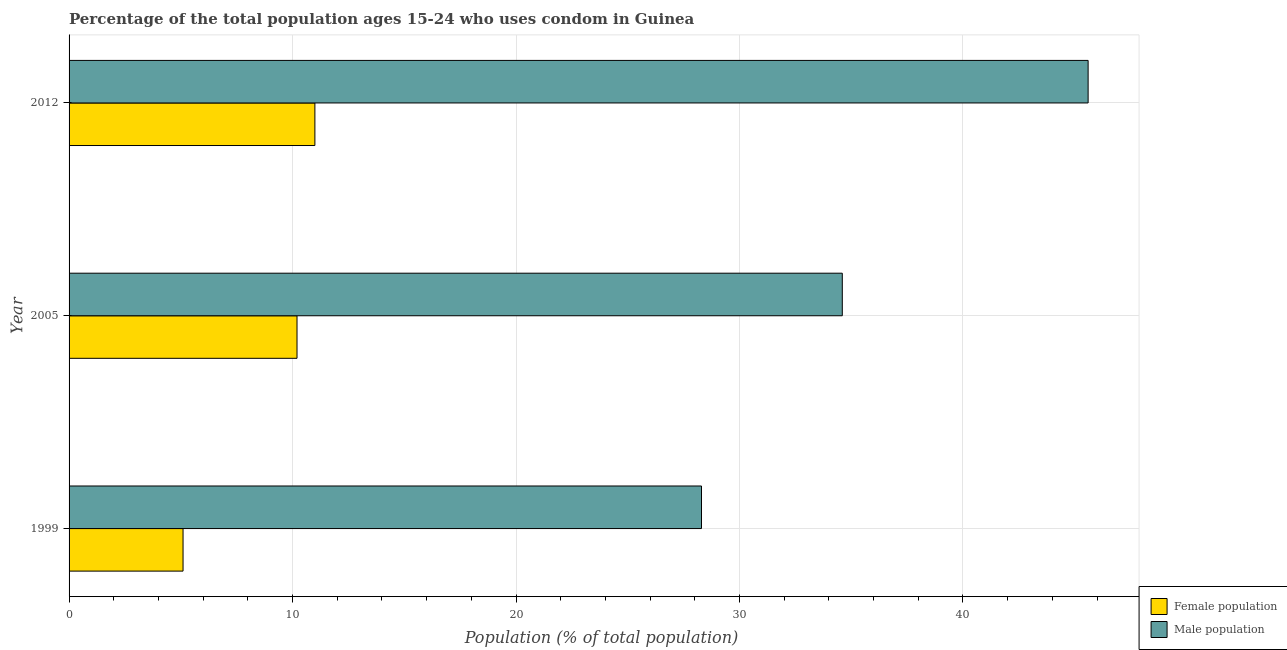How many different coloured bars are there?
Give a very brief answer. 2. How many bars are there on the 2nd tick from the bottom?
Give a very brief answer. 2. In how many cases, is the number of bars for a given year not equal to the number of legend labels?
Your answer should be compact. 0. What is the male population in 1999?
Your answer should be very brief. 28.3. Across all years, what is the maximum male population?
Keep it short and to the point. 45.6. In which year was the male population maximum?
Offer a terse response. 2012. In which year was the female population minimum?
Offer a terse response. 1999. What is the total female population in the graph?
Keep it short and to the point. 26.3. What is the difference between the male population in 2005 and the female population in 2012?
Give a very brief answer. 23.6. What is the average male population per year?
Your response must be concise. 36.17. In the year 1999, what is the difference between the male population and female population?
Make the answer very short. 23.2. In how many years, is the female population greater than 34 %?
Your answer should be very brief. 0. What is the ratio of the male population in 2005 to that in 2012?
Offer a very short reply. 0.76. Is the male population in 1999 less than that in 2012?
Offer a very short reply. Yes. Is the difference between the female population in 1999 and 2005 greater than the difference between the male population in 1999 and 2005?
Give a very brief answer. Yes. What is the difference between the highest and the second highest female population?
Give a very brief answer. 0.8. Is the sum of the female population in 1999 and 2012 greater than the maximum male population across all years?
Your answer should be very brief. No. What does the 2nd bar from the top in 2005 represents?
Offer a terse response. Female population. What does the 1st bar from the bottom in 2012 represents?
Your answer should be compact. Female population. Are the values on the major ticks of X-axis written in scientific E-notation?
Offer a very short reply. No. Does the graph contain grids?
Offer a very short reply. Yes. How are the legend labels stacked?
Offer a terse response. Vertical. What is the title of the graph?
Make the answer very short. Percentage of the total population ages 15-24 who uses condom in Guinea. Does "GDP" appear as one of the legend labels in the graph?
Your answer should be very brief. No. What is the label or title of the X-axis?
Provide a succinct answer. Population (% of total population) . What is the label or title of the Y-axis?
Your answer should be compact. Year. What is the Population (% of total population)  in Female population in 1999?
Keep it short and to the point. 5.1. What is the Population (% of total population)  of Male population in 1999?
Keep it short and to the point. 28.3. What is the Population (% of total population)  in Female population in 2005?
Keep it short and to the point. 10.2. What is the Population (% of total population)  of Male population in 2005?
Your response must be concise. 34.6. What is the Population (% of total population)  of Male population in 2012?
Ensure brevity in your answer.  45.6. Across all years, what is the maximum Population (% of total population)  of Female population?
Provide a succinct answer. 11. Across all years, what is the maximum Population (% of total population)  in Male population?
Provide a succinct answer. 45.6. Across all years, what is the minimum Population (% of total population)  of Female population?
Give a very brief answer. 5.1. Across all years, what is the minimum Population (% of total population)  of Male population?
Provide a succinct answer. 28.3. What is the total Population (% of total population)  in Female population in the graph?
Your answer should be compact. 26.3. What is the total Population (% of total population)  of Male population in the graph?
Ensure brevity in your answer.  108.5. What is the difference between the Population (% of total population)  of Female population in 1999 and that in 2005?
Your response must be concise. -5.1. What is the difference between the Population (% of total population)  of Male population in 1999 and that in 2005?
Your response must be concise. -6.3. What is the difference between the Population (% of total population)  in Male population in 1999 and that in 2012?
Give a very brief answer. -17.3. What is the difference between the Population (% of total population)  in Male population in 2005 and that in 2012?
Provide a short and direct response. -11. What is the difference between the Population (% of total population)  of Female population in 1999 and the Population (% of total population)  of Male population in 2005?
Your answer should be very brief. -29.5. What is the difference between the Population (% of total population)  in Female population in 1999 and the Population (% of total population)  in Male population in 2012?
Your answer should be very brief. -40.5. What is the difference between the Population (% of total population)  of Female population in 2005 and the Population (% of total population)  of Male population in 2012?
Give a very brief answer. -35.4. What is the average Population (% of total population)  in Female population per year?
Provide a succinct answer. 8.77. What is the average Population (% of total population)  in Male population per year?
Provide a succinct answer. 36.17. In the year 1999, what is the difference between the Population (% of total population)  in Female population and Population (% of total population)  in Male population?
Provide a succinct answer. -23.2. In the year 2005, what is the difference between the Population (% of total population)  of Female population and Population (% of total population)  of Male population?
Provide a succinct answer. -24.4. In the year 2012, what is the difference between the Population (% of total population)  in Female population and Population (% of total population)  in Male population?
Offer a terse response. -34.6. What is the ratio of the Population (% of total population)  in Female population in 1999 to that in 2005?
Offer a terse response. 0.5. What is the ratio of the Population (% of total population)  in Male population in 1999 to that in 2005?
Your response must be concise. 0.82. What is the ratio of the Population (% of total population)  in Female population in 1999 to that in 2012?
Make the answer very short. 0.46. What is the ratio of the Population (% of total population)  in Male population in 1999 to that in 2012?
Your answer should be compact. 0.62. What is the ratio of the Population (% of total population)  in Female population in 2005 to that in 2012?
Your answer should be very brief. 0.93. What is the ratio of the Population (% of total population)  in Male population in 2005 to that in 2012?
Give a very brief answer. 0.76. What is the difference between the highest and the second highest Population (% of total population)  of Female population?
Keep it short and to the point. 0.8. 